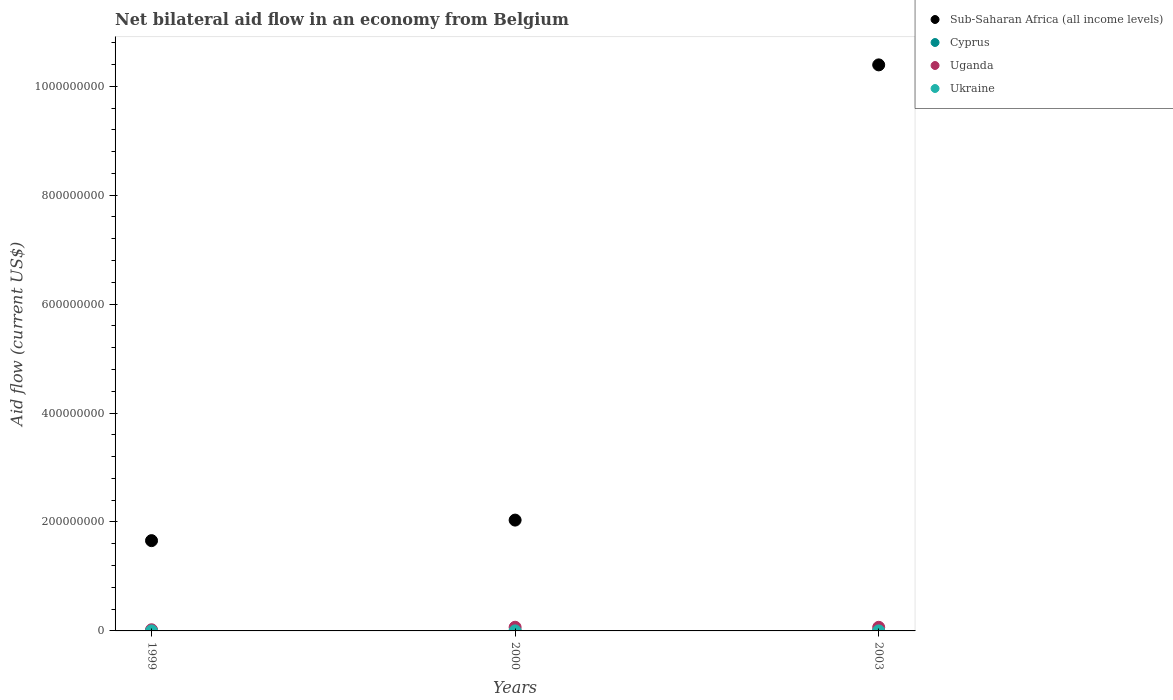Is the number of dotlines equal to the number of legend labels?
Give a very brief answer. Yes. What is the net bilateral aid flow in Uganda in 2000?
Your response must be concise. 6.73e+06. Across all years, what is the maximum net bilateral aid flow in Ukraine?
Your answer should be very brief. 4.00e+04. Across all years, what is the minimum net bilateral aid flow in Uganda?
Provide a short and direct response. 2.12e+06. What is the total net bilateral aid flow in Ukraine in the graph?
Ensure brevity in your answer.  1.20e+05. What is the difference between the net bilateral aid flow in Ukraine in 1999 and that in 2000?
Offer a very short reply. 0. What is the difference between the net bilateral aid flow in Sub-Saharan Africa (all income levels) in 2003 and the net bilateral aid flow in Uganda in 1999?
Give a very brief answer. 1.04e+09. In the year 1999, what is the difference between the net bilateral aid flow in Ukraine and net bilateral aid flow in Cyprus?
Keep it short and to the point. -3.40e+05. In how many years, is the net bilateral aid flow in Ukraine greater than 400000000 US$?
Offer a very short reply. 0. What is the ratio of the net bilateral aid flow in Cyprus in 2000 to that in 2003?
Your answer should be compact. 1. Is the net bilateral aid flow in Cyprus in 1999 less than that in 2003?
Your answer should be very brief. No. What is the difference between the highest and the second highest net bilateral aid flow in Ukraine?
Your answer should be very brief. 0. What is the difference between the highest and the lowest net bilateral aid flow in Uganda?
Provide a succinct answer. 4.61e+06. In how many years, is the net bilateral aid flow in Sub-Saharan Africa (all income levels) greater than the average net bilateral aid flow in Sub-Saharan Africa (all income levels) taken over all years?
Make the answer very short. 1. Is the sum of the net bilateral aid flow in Uganda in 2000 and 2003 greater than the maximum net bilateral aid flow in Ukraine across all years?
Give a very brief answer. Yes. Is it the case that in every year, the sum of the net bilateral aid flow in Cyprus and net bilateral aid flow in Sub-Saharan Africa (all income levels)  is greater than the net bilateral aid flow in Ukraine?
Make the answer very short. Yes. Is the net bilateral aid flow in Ukraine strictly greater than the net bilateral aid flow in Cyprus over the years?
Provide a short and direct response. No. How many years are there in the graph?
Offer a very short reply. 3. Are the values on the major ticks of Y-axis written in scientific E-notation?
Provide a short and direct response. No. Does the graph contain any zero values?
Offer a terse response. No. How many legend labels are there?
Give a very brief answer. 4. What is the title of the graph?
Make the answer very short. Net bilateral aid flow in an economy from Belgium. Does "Greece" appear as one of the legend labels in the graph?
Your response must be concise. No. What is the label or title of the X-axis?
Your answer should be very brief. Years. What is the label or title of the Y-axis?
Make the answer very short. Aid flow (current US$). What is the Aid flow (current US$) in Sub-Saharan Africa (all income levels) in 1999?
Your response must be concise. 1.66e+08. What is the Aid flow (current US$) in Cyprus in 1999?
Your response must be concise. 3.80e+05. What is the Aid flow (current US$) in Uganda in 1999?
Offer a terse response. 2.12e+06. What is the Aid flow (current US$) in Sub-Saharan Africa (all income levels) in 2000?
Provide a short and direct response. 2.03e+08. What is the Aid flow (current US$) of Uganda in 2000?
Your response must be concise. 6.73e+06. What is the Aid flow (current US$) in Sub-Saharan Africa (all income levels) in 2003?
Keep it short and to the point. 1.04e+09. What is the Aid flow (current US$) in Cyprus in 2003?
Your answer should be compact. 1.20e+05. What is the Aid flow (current US$) of Uganda in 2003?
Your answer should be very brief. 6.64e+06. What is the Aid flow (current US$) of Ukraine in 2003?
Your answer should be compact. 4.00e+04. Across all years, what is the maximum Aid flow (current US$) in Sub-Saharan Africa (all income levels)?
Give a very brief answer. 1.04e+09. Across all years, what is the maximum Aid flow (current US$) in Cyprus?
Keep it short and to the point. 3.80e+05. Across all years, what is the maximum Aid flow (current US$) of Uganda?
Offer a terse response. 6.73e+06. Across all years, what is the maximum Aid flow (current US$) in Ukraine?
Offer a very short reply. 4.00e+04. Across all years, what is the minimum Aid flow (current US$) in Sub-Saharan Africa (all income levels)?
Your response must be concise. 1.66e+08. Across all years, what is the minimum Aid flow (current US$) of Uganda?
Your answer should be very brief. 2.12e+06. Across all years, what is the minimum Aid flow (current US$) in Ukraine?
Provide a short and direct response. 4.00e+04. What is the total Aid flow (current US$) of Sub-Saharan Africa (all income levels) in the graph?
Your answer should be very brief. 1.41e+09. What is the total Aid flow (current US$) in Cyprus in the graph?
Provide a succinct answer. 6.20e+05. What is the total Aid flow (current US$) in Uganda in the graph?
Give a very brief answer. 1.55e+07. What is the total Aid flow (current US$) of Ukraine in the graph?
Ensure brevity in your answer.  1.20e+05. What is the difference between the Aid flow (current US$) of Sub-Saharan Africa (all income levels) in 1999 and that in 2000?
Provide a short and direct response. -3.77e+07. What is the difference between the Aid flow (current US$) of Cyprus in 1999 and that in 2000?
Give a very brief answer. 2.60e+05. What is the difference between the Aid flow (current US$) in Uganda in 1999 and that in 2000?
Your answer should be very brief. -4.61e+06. What is the difference between the Aid flow (current US$) in Sub-Saharan Africa (all income levels) in 1999 and that in 2003?
Make the answer very short. -8.73e+08. What is the difference between the Aid flow (current US$) in Cyprus in 1999 and that in 2003?
Ensure brevity in your answer.  2.60e+05. What is the difference between the Aid flow (current US$) in Uganda in 1999 and that in 2003?
Give a very brief answer. -4.52e+06. What is the difference between the Aid flow (current US$) of Sub-Saharan Africa (all income levels) in 2000 and that in 2003?
Your answer should be compact. -8.36e+08. What is the difference between the Aid flow (current US$) of Cyprus in 2000 and that in 2003?
Keep it short and to the point. 0. What is the difference between the Aid flow (current US$) of Sub-Saharan Africa (all income levels) in 1999 and the Aid flow (current US$) of Cyprus in 2000?
Your answer should be compact. 1.66e+08. What is the difference between the Aid flow (current US$) in Sub-Saharan Africa (all income levels) in 1999 and the Aid flow (current US$) in Uganda in 2000?
Offer a very short reply. 1.59e+08. What is the difference between the Aid flow (current US$) in Sub-Saharan Africa (all income levels) in 1999 and the Aid flow (current US$) in Ukraine in 2000?
Give a very brief answer. 1.66e+08. What is the difference between the Aid flow (current US$) in Cyprus in 1999 and the Aid flow (current US$) in Uganda in 2000?
Give a very brief answer. -6.35e+06. What is the difference between the Aid flow (current US$) in Uganda in 1999 and the Aid flow (current US$) in Ukraine in 2000?
Your response must be concise. 2.08e+06. What is the difference between the Aid flow (current US$) in Sub-Saharan Africa (all income levels) in 1999 and the Aid flow (current US$) in Cyprus in 2003?
Your answer should be very brief. 1.66e+08. What is the difference between the Aid flow (current US$) in Sub-Saharan Africa (all income levels) in 1999 and the Aid flow (current US$) in Uganda in 2003?
Ensure brevity in your answer.  1.59e+08. What is the difference between the Aid flow (current US$) in Sub-Saharan Africa (all income levels) in 1999 and the Aid flow (current US$) in Ukraine in 2003?
Offer a very short reply. 1.66e+08. What is the difference between the Aid flow (current US$) in Cyprus in 1999 and the Aid flow (current US$) in Uganda in 2003?
Provide a succinct answer. -6.26e+06. What is the difference between the Aid flow (current US$) in Cyprus in 1999 and the Aid flow (current US$) in Ukraine in 2003?
Offer a very short reply. 3.40e+05. What is the difference between the Aid flow (current US$) of Uganda in 1999 and the Aid flow (current US$) of Ukraine in 2003?
Offer a terse response. 2.08e+06. What is the difference between the Aid flow (current US$) in Sub-Saharan Africa (all income levels) in 2000 and the Aid flow (current US$) in Cyprus in 2003?
Offer a very short reply. 2.03e+08. What is the difference between the Aid flow (current US$) in Sub-Saharan Africa (all income levels) in 2000 and the Aid flow (current US$) in Uganda in 2003?
Provide a short and direct response. 1.97e+08. What is the difference between the Aid flow (current US$) in Sub-Saharan Africa (all income levels) in 2000 and the Aid flow (current US$) in Ukraine in 2003?
Your answer should be compact. 2.03e+08. What is the difference between the Aid flow (current US$) of Cyprus in 2000 and the Aid flow (current US$) of Uganda in 2003?
Give a very brief answer. -6.52e+06. What is the difference between the Aid flow (current US$) of Cyprus in 2000 and the Aid flow (current US$) of Ukraine in 2003?
Provide a succinct answer. 8.00e+04. What is the difference between the Aid flow (current US$) of Uganda in 2000 and the Aid flow (current US$) of Ukraine in 2003?
Your response must be concise. 6.69e+06. What is the average Aid flow (current US$) of Sub-Saharan Africa (all income levels) per year?
Your answer should be compact. 4.69e+08. What is the average Aid flow (current US$) in Cyprus per year?
Your answer should be very brief. 2.07e+05. What is the average Aid flow (current US$) in Uganda per year?
Your response must be concise. 5.16e+06. What is the average Aid flow (current US$) of Ukraine per year?
Give a very brief answer. 4.00e+04. In the year 1999, what is the difference between the Aid flow (current US$) in Sub-Saharan Africa (all income levels) and Aid flow (current US$) in Cyprus?
Keep it short and to the point. 1.65e+08. In the year 1999, what is the difference between the Aid flow (current US$) in Sub-Saharan Africa (all income levels) and Aid flow (current US$) in Uganda?
Provide a short and direct response. 1.64e+08. In the year 1999, what is the difference between the Aid flow (current US$) of Sub-Saharan Africa (all income levels) and Aid flow (current US$) of Ukraine?
Give a very brief answer. 1.66e+08. In the year 1999, what is the difference between the Aid flow (current US$) of Cyprus and Aid flow (current US$) of Uganda?
Offer a very short reply. -1.74e+06. In the year 1999, what is the difference between the Aid flow (current US$) in Uganda and Aid flow (current US$) in Ukraine?
Provide a succinct answer. 2.08e+06. In the year 2000, what is the difference between the Aid flow (current US$) of Sub-Saharan Africa (all income levels) and Aid flow (current US$) of Cyprus?
Provide a succinct answer. 2.03e+08. In the year 2000, what is the difference between the Aid flow (current US$) in Sub-Saharan Africa (all income levels) and Aid flow (current US$) in Uganda?
Provide a succinct answer. 1.97e+08. In the year 2000, what is the difference between the Aid flow (current US$) in Sub-Saharan Africa (all income levels) and Aid flow (current US$) in Ukraine?
Make the answer very short. 2.03e+08. In the year 2000, what is the difference between the Aid flow (current US$) in Cyprus and Aid flow (current US$) in Uganda?
Offer a terse response. -6.61e+06. In the year 2000, what is the difference between the Aid flow (current US$) of Uganda and Aid flow (current US$) of Ukraine?
Give a very brief answer. 6.69e+06. In the year 2003, what is the difference between the Aid flow (current US$) in Sub-Saharan Africa (all income levels) and Aid flow (current US$) in Cyprus?
Provide a succinct answer. 1.04e+09. In the year 2003, what is the difference between the Aid flow (current US$) in Sub-Saharan Africa (all income levels) and Aid flow (current US$) in Uganda?
Keep it short and to the point. 1.03e+09. In the year 2003, what is the difference between the Aid flow (current US$) in Sub-Saharan Africa (all income levels) and Aid flow (current US$) in Ukraine?
Provide a short and direct response. 1.04e+09. In the year 2003, what is the difference between the Aid flow (current US$) in Cyprus and Aid flow (current US$) in Uganda?
Offer a terse response. -6.52e+06. In the year 2003, what is the difference between the Aid flow (current US$) in Uganda and Aid flow (current US$) in Ukraine?
Your response must be concise. 6.60e+06. What is the ratio of the Aid flow (current US$) of Sub-Saharan Africa (all income levels) in 1999 to that in 2000?
Provide a succinct answer. 0.81. What is the ratio of the Aid flow (current US$) in Cyprus in 1999 to that in 2000?
Provide a succinct answer. 3.17. What is the ratio of the Aid flow (current US$) of Uganda in 1999 to that in 2000?
Offer a very short reply. 0.32. What is the ratio of the Aid flow (current US$) of Ukraine in 1999 to that in 2000?
Your answer should be compact. 1. What is the ratio of the Aid flow (current US$) of Sub-Saharan Africa (all income levels) in 1999 to that in 2003?
Provide a succinct answer. 0.16. What is the ratio of the Aid flow (current US$) in Cyprus in 1999 to that in 2003?
Your response must be concise. 3.17. What is the ratio of the Aid flow (current US$) in Uganda in 1999 to that in 2003?
Offer a very short reply. 0.32. What is the ratio of the Aid flow (current US$) of Sub-Saharan Africa (all income levels) in 2000 to that in 2003?
Offer a terse response. 0.2. What is the ratio of the Aid flow (current US$) of Uganda in 2000 to that in 2003?
Keep it short and to the point. 1.01. What is the difference between the highest and the second highest Aid flow (current US$) of Sub-Saharan Africa (all income levels)?
Give a very brief answer. 8.36e+08. What is the difference between the highest and the second highest Aid flow (current US$) in Cyprus?
Offer a very short reply. 2.60e+05. What is the difference between the highest and the second highest Aid flow (current US$) of Uganda?
Your answer should be very brief. 9.00e+04. What is the difference between the highest and the lowest Aid flow (current US$) in Sub-Saharan Africa (all income levels)?
Make the answer very short. 8.73e+08. What is the difference between the highest and the lowest Aid flow (current US$) of Uganda?
Offer a very short reply. 4.61e+06. What is the difference between the highest and the lowest Aid flow (current US$) of Ukraine?
Provide a short and direct response. 0. 